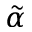Convert formula to latex. <formula><loc_0><loc_0><loc_500><loc_500>\tilde { \alpha }</formula> 